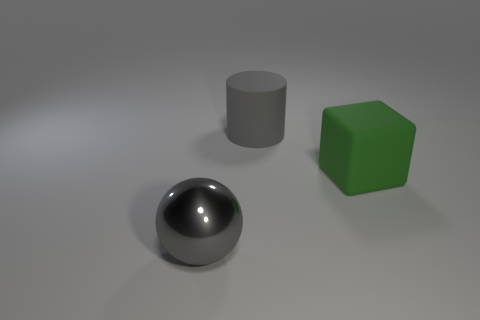Does the large sphere have the same material as the large green object?
Your response must be concise. No. What number of blue spheres are made of the same material as the big green object?
Give a very brief answer. 0. What number of objects are gray objects behind the metallic object or big gray objects that are behind the sphere?
Your response must be concise. 1. Are there more large green cubes in front of the green object than green rubber cubes on the left side of the gray sphere?
Your answer should be compact. No. What is the color of the matte thing behind the large green matte thing?
Offer a terse response. Gray. Are there any other large things that have the same shape as the large shiny thing?
Your answer should be compact. No. How many yellow things are either large metal spheres or matte objects?
Your answer should be compact. 0. Are there any other things of the same size as the green thing?
Your answer should be compact. Yes. What number of objects are there?
Your answer should be compact. 3. What number of large objects are either metallic balls or green things?
Your response must be concise. 2. 